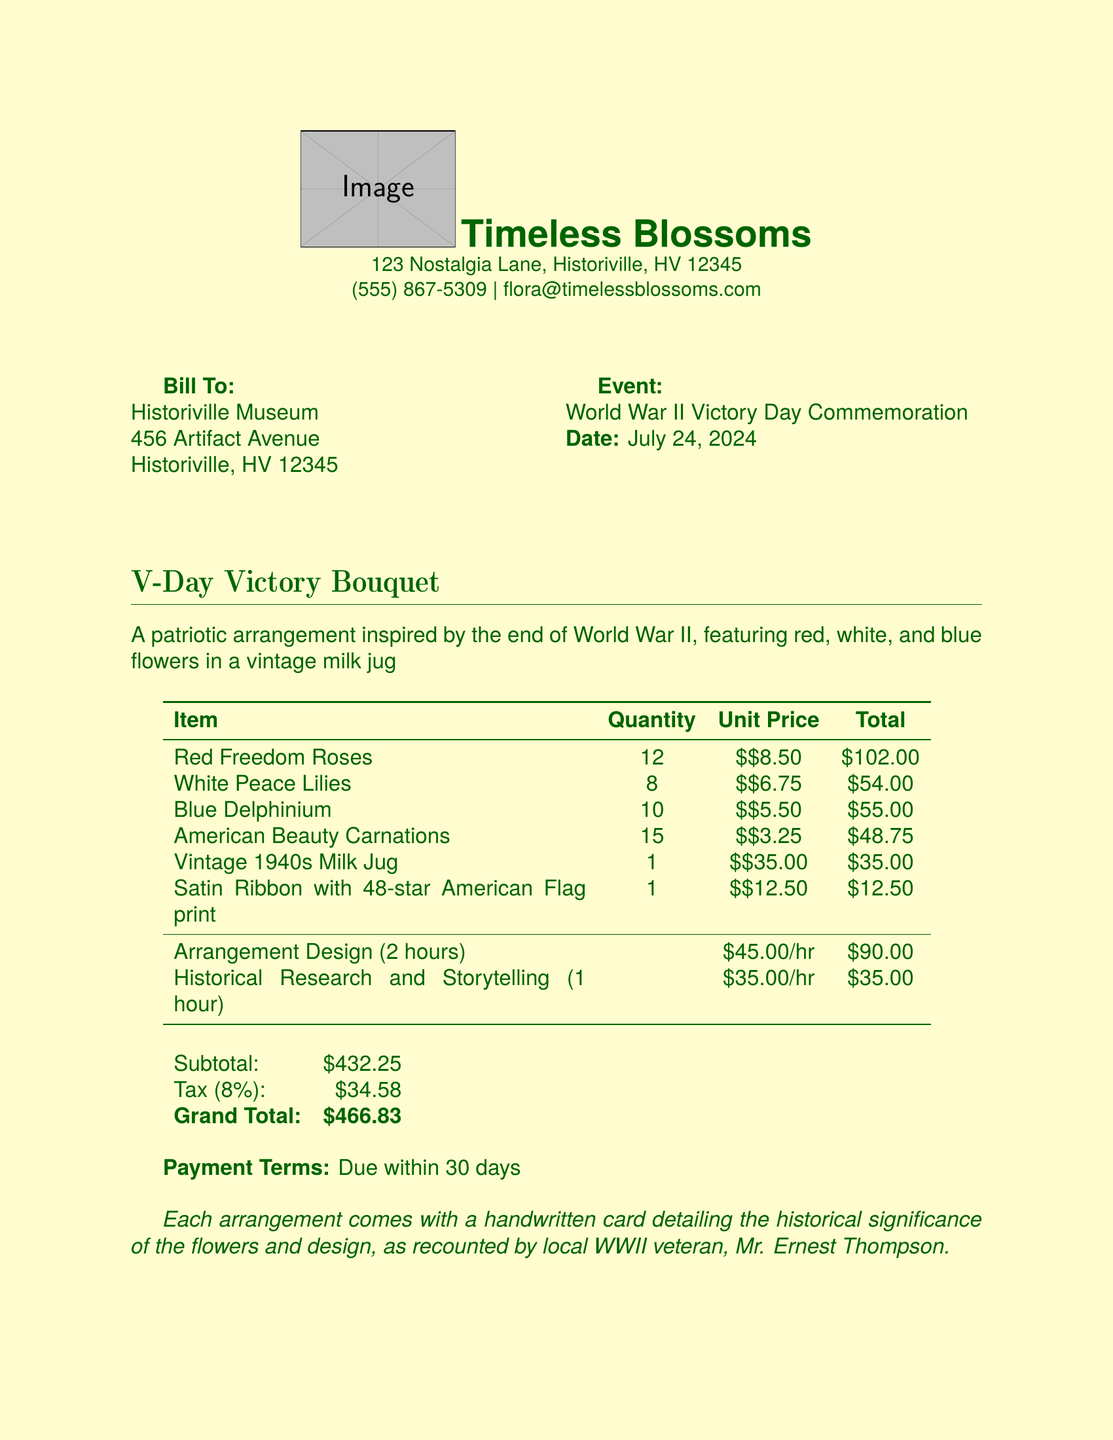What is the name of the florist? The document lists "Timeless Blossoms" as the florist's name.
Answer: Timeless Blossoms What is the total cost of red freedom roses? The total cost is calculated as 12 roses at $8.50 each, which totals $102.00.
Answer: $102.00 What is the event for which the floral arrangement is made? The event is titled "World War II Victory Day Commemoration."
Answer: World War II Victory Day Commemoration What is the grand total amount due? The grand total is indicated at the bottom of the invoice as $466.83.
Answer: $466.83 How many hours were spent on designing the arrangement? There were 2 hours spent on arrangement design as stated in the labor section.
Answer: 2 hours What percentage tax is applied to the invoice? The tax applied is stated as 8%.
Answer: 8% Who provided the historical significance for the arrangement? The historical significance was recounted by local WWII veteran, Mr. Ernest Thompson.
Answer: Mr. Ernest Thompson Which flower has the highest unit price? The highest unit price is for the red freedom roses at $8.50 each.
Answer: $8.50 What is the payment term mentioned in the invoice? The payment terms specified state that it is due within 30 days.
Answer: Due within 30 days 